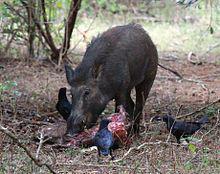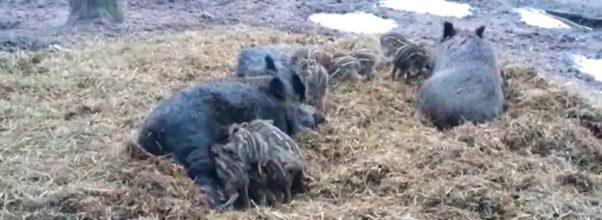The first image is the image on the left, the second image is the image on the right. Evaluate the accuracy of this statement regarding the images: "The combined images include at least three piglets standing on all fours, and all piglets are near a standing adult pig.". Is it true? Answer yes or no. No. 